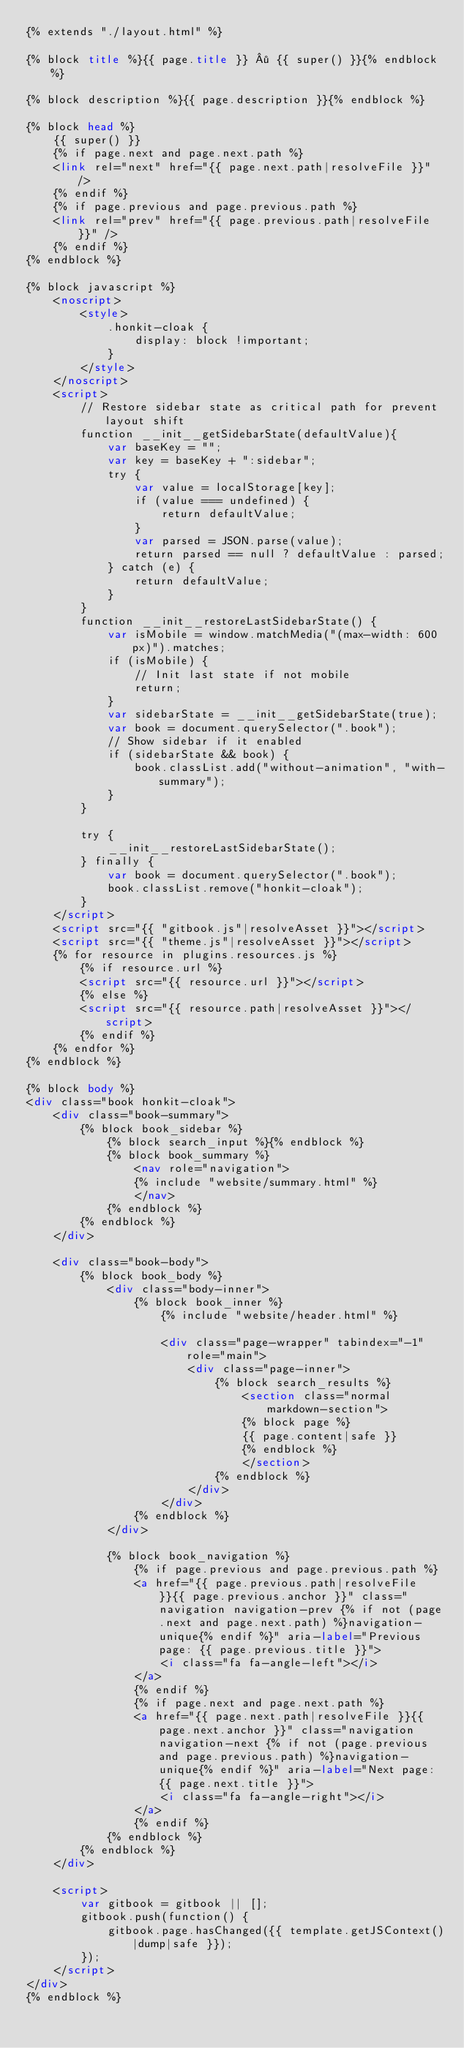Convert code to text. <code><loc_0><loc_0><loc_500><loc_500><_HTML_>{% extends "./layout.html" %}

{% block title %}{{ page.title }} · {{ super() }}{% endblock %}

{% block description %}{{ page.description }}{% endblock %}

{% block head %}
    {{ super() }}
    {% if page.next and page.next.path %}
    <link rel="next" href="{{ page.next.path|resolveFile }}" />
    {% endif %}
    {% if page.previous and page.previous.path %}
    <link rel="prev" href="{{ page.previous.path|resolveFile }}" />
    {% endif %}
{% endblock %}

{% block javascript %}
    <noscript>
        <style>
            .honkit-cloak {
                display: block !important;
            }
        </style>
    </noscript>
    <script>
        // Restore sidebar state as critical path for prevent layout shift
        function __init__getSidebarState(defaultValue){
            var baseKey = "";
            var key = baseKey + ":sidebar";
            try {
                var value = localStorage[key];
                if (value === undefined) {
                    return defaultValue;
                }
                var parsed = JSON.parse(value);
                return parsed == null ? defaultValue : parsed;
            } catch (e) {
                return defaultValue;
            }
        }
        function __init__restoreLastSidebarState() {
            var isMobile = window.matchMedia("(max-width: 600px)").matches;
            if (isMobile) {
                // Init last state if not mobile
                return;
            }
            var sidebarState = __init__getSidebarState(true);
            var book = document.querySelector(".book");
            // Show sidebar if it enabled
            if (sidebarState && book) {
                book.classList.add("without-animation", "with-summary");
            }
        }

        try {
            __init__restoreLastSidebarState();
        } finally {
            var book = document.querySelector(".book");
            book.classList.remove("honkit-cloak");
        }
    </script>
    <script src="{{ "gitbook.js"|resolveAsset }}"></script>
    <script src="{{ "theme.js"|resolveAsset }}"></script>
    {% for resource in plugins.resources.js %}
        {% if resource.url %}
        <script src="{{ resource.url }}"></script>
        {% else %}
        <script src="{{ resource.path|resolveAsset }}"></script>
        {% endif %}
    {% endfor %}
{% endblock %}

{% block body %}
<div class="book honkit-cloak">
    <div class="book-summary">
        {% block book_sidebar %}
            {% block search_input %}{% endblock %}
            {% block book_summary %}
                <nav role="navigation">
                {% include "website/summary.html" %}
                </nav>
            {% endblock %}
        {% endblock %}
    </div>

    <div class="book-body">
        {% block book_body %}
            <div class="body-inner">
                {% block book_inner %}
                    {% include "website/header.html" %}

                    <div class="page-wrapper" tabindex="-1" role="main">
                        <div class="page-inner">
                            {% block search_results %}
                                <section class="normal markdown-section">
                                {% block page %}
                                {{ page.content|safe }}
                                {% endblock %}
                                </section>
                            {% endblock %}
                        </div>
                    </div>
                {% endblock %}
            </div>

            {% block book_navigation %}
                {% if page.previous and page.previous.path %}
                <a href="{{ page.previous.path|resolveFile }}{{ page.previous.anchor }}" class="navigation navigation-prev {% if not (page.next and page.next.path) %}navigation-unique{% endif %}" aria-label="Previous page: {{ page.previous.title }}">
                    <i class="fa fa-angle-left"></i>
                </a>
                {% endif %}
                {% if page.next and page.next.path %}
                <a href="{{ page.next.path|resolveFile }}{{ page.next.anchor }}" class="navigation navigation-next {% if not (page.previous and page.previous.path) %}navigation-unique{% endif %}" aria-label="Next page: {{ page.next.title }}">
                    <i class="fa fa-angle-right"></i>
                </a>
                {% endif %}
            {% endblock %}
        {% endblock %}
    </div>

    <script>
        var gitbook = gitbook || [];
        gitbook.push(function() {
            gitbook.page.hasChanged({{ template.getJSContext()|dump|safe }});
        });
    </script>
</div>
{% endblock %}
</code> 